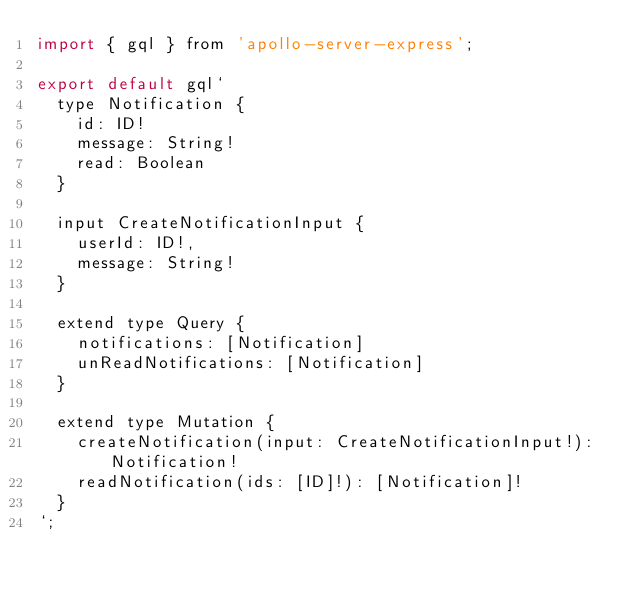<code> <loc_0><loc_0><loc_500><loc_500><_JavaScript_>import { gql } from 'apollo-server-express';

export default gql`
  type Notification {
    id: ID!
    message: String!
    read: Boolean
  }

  input CreateNotificationInput {
    userId: ID!,
    message: String!
  }

  extend type Query {
    notifications: [Notification]
    unReadNotifications: [Notification]
  }

  extend type Mutation {
    createNotification(input: CreateNotificationInput!): Notification!
    readNotification(ids: [ID]!): [Notification]!
  }
`;
</code> 